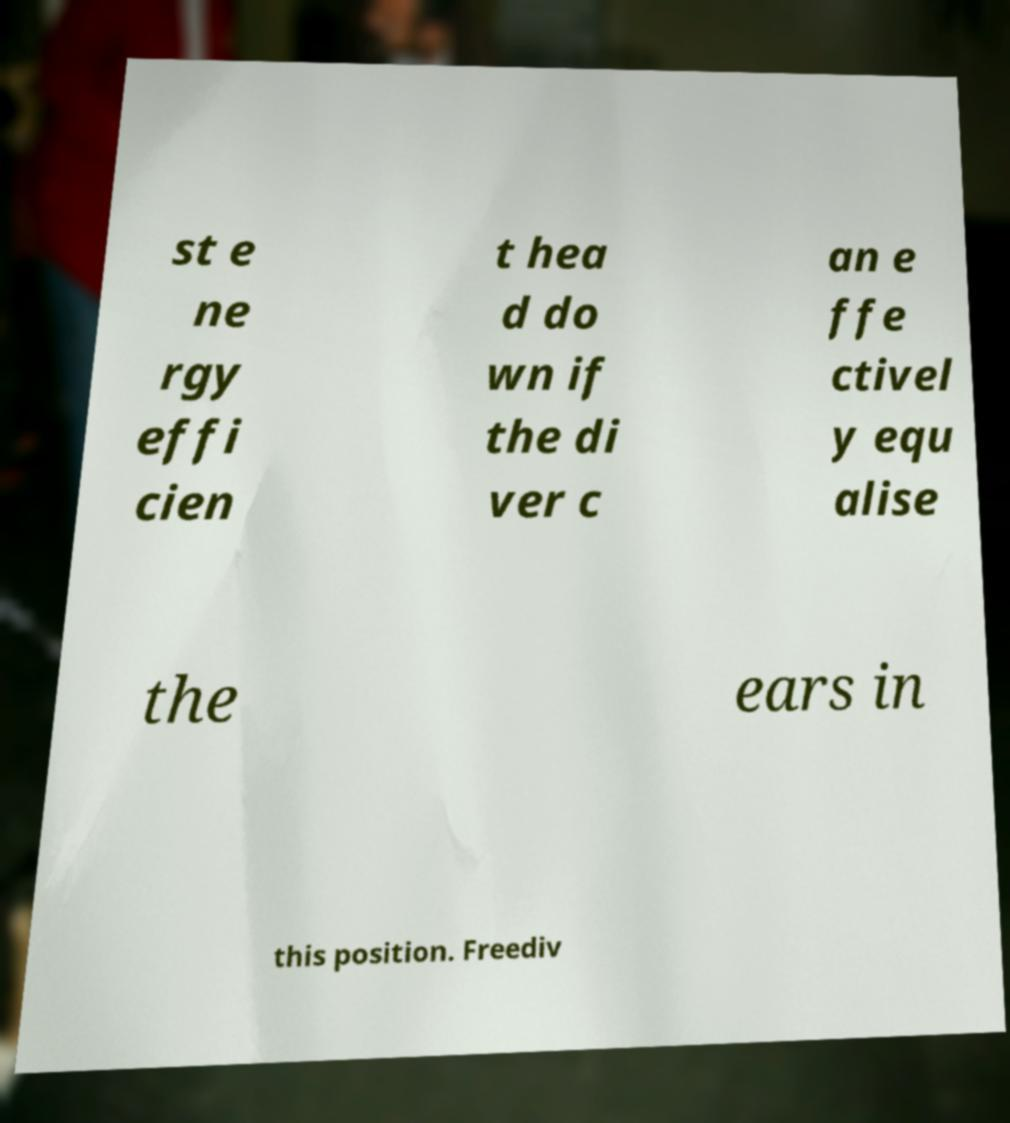Can you accurately transcribe the text from the provided image for me? st e ne rgy effi cien t hea d do wn if the di ver c an e ffe ctivel y equ alise the ears in this position. Freediv 